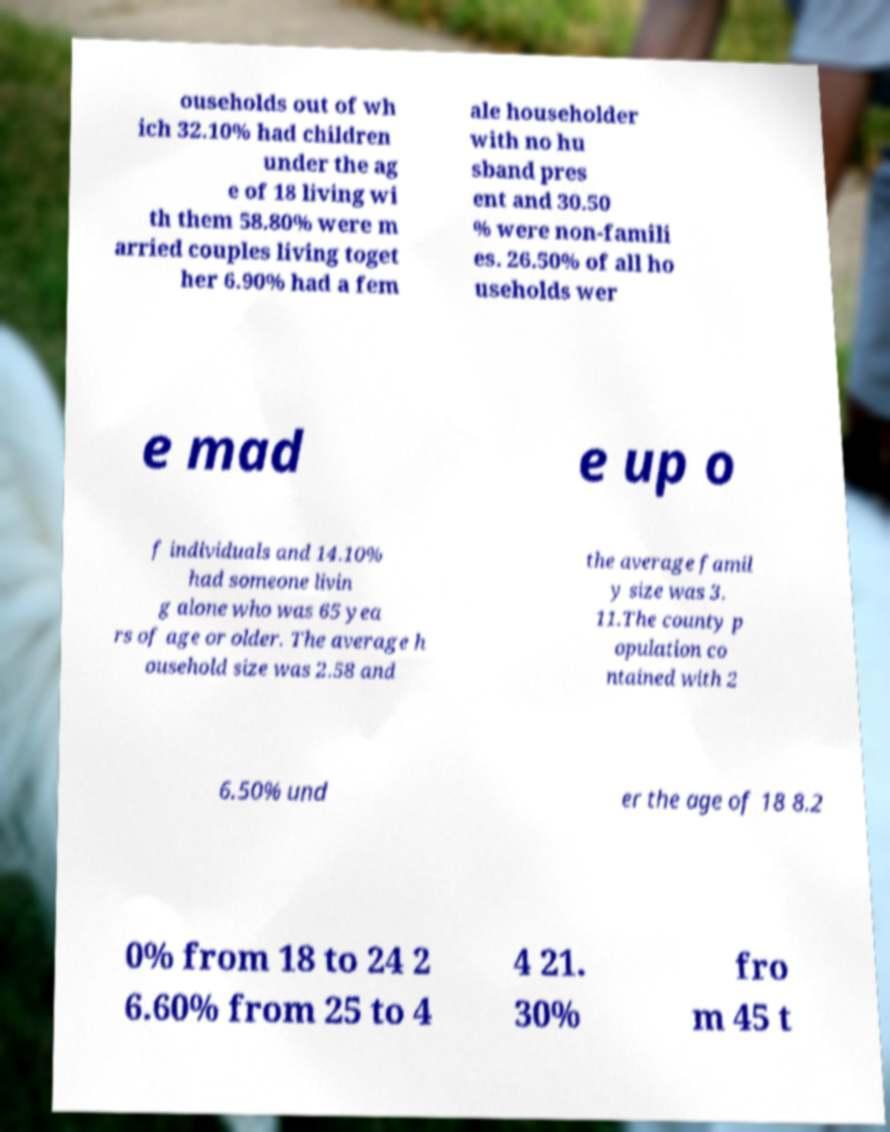What messages or text are displayed in this image? I need them in a readable, typed format. ouseholds out of wh ich 32.10% had children under the ag e of 18 living wi th them 58.80% were m arried couples living toget her 6.90% had a fem ale householder with no hu sband pres ent and 30.50 % were non-famili es. 26.50% of all ho useholds wer e mad e up o f individuals and 14.10% had someone livin g alone who was 65 yea rs of age or older. The average h ousehold size was 2.58 and the average famil y size was 3. 11.The county p opulation co ntained with 2 6.50% und er the age of 18 8.2 0% from 18 to 24 2 6.60% from 25 to 4 4 21. 30% fro m 45 t 